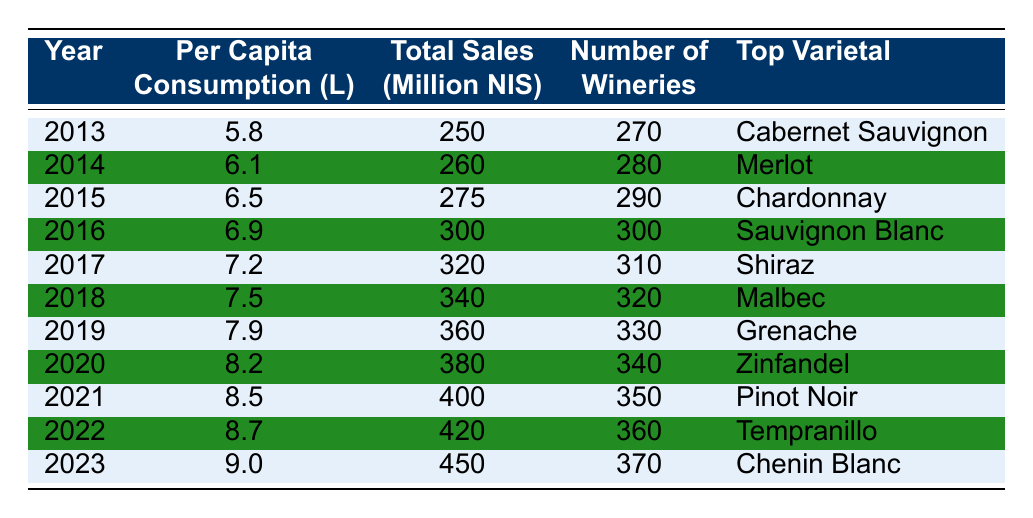What was the per capita wine consumption in Israel in 2015? According to the table, the row for the year 2015 shows a per capita consumption of 6.5 liters.
Answer: 6.5 liters Which year had the highest total sales in million NIS? By scanning the 'Total Sales' column for each year, the highest sales were in the year 2023 with 450 million NIS.
Answer: 2023 What is the average per capita wine consumption from 2013 to 2023? The sum of per capita consumption values from 2013 to 2023 is (5.8 + 6.1 + 6.5 + 6.9 + 7.2 + 7.5 + 7.9 + 8.2 + 8.5 + 8.7 + 9.0) = 77.8. There are 11 years, so 77.8/11 = 7.09.
Answer: 7.09 liters Has the number of wineries increased every year? By examining the 'Number of Wineries' column, each subsequent year from 2013 to 2023 shows an increase in the number of wineries.
Answer: Yes What was the total sales growth from 2013 to 2023? The total sales in 2013 were 250 million NIS and in 2023 were 450 million NIS. The growth is calculated as (450 - 250) = 200 million NIS.
Answer: 200 million NIS Which varietal had the highest consumption in 2019? Referring to the table, the top varietal listed for 2019 is Grenache.
Answer: Grenache In which year did per capita consumption first exceed 8 liters? Looking through the per capita consumption values, it first exceeded 8 liters in 2020.
Answer: 2020 What is the change in the number of wineries from 2013 to 2023? The number of wineries in 2013 was 270 and in 2023 was 370. The change is (370 - 270) = 100 wineries.
Answer: 100 wineries What was the top varietal in 2022? The table lists Tempranillo as the top varietal for the year 2022.
Answer: Tempranillo Did total sales decrease in any year from 2013 to 2023? A review of the 'Total Sales' column shows that there were no decreases; sales increased every year from 2013 to 2023.
Answer: No 